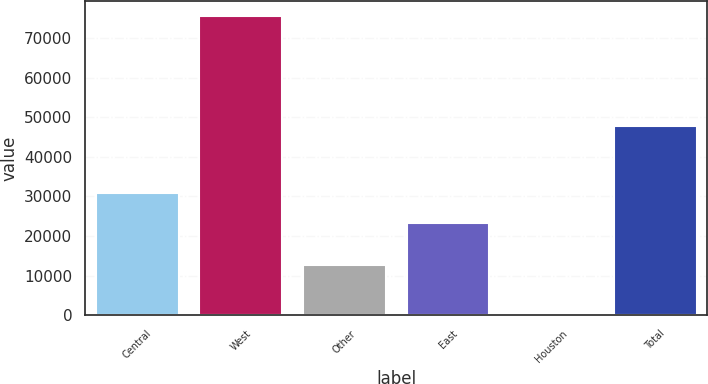Convert chart to OTSL. <chart><loc_0><loc_0><loc_500><loc_500><bar_chart><fcel>Central<fcel>West<fcel>Other<fcel>East<fcel>Houston<fcel>Total<nl><fcel>30798.7<fcel>75614<fcel>12709<fcel>23251<fcel>137<fcel>47791<nl></chart> 